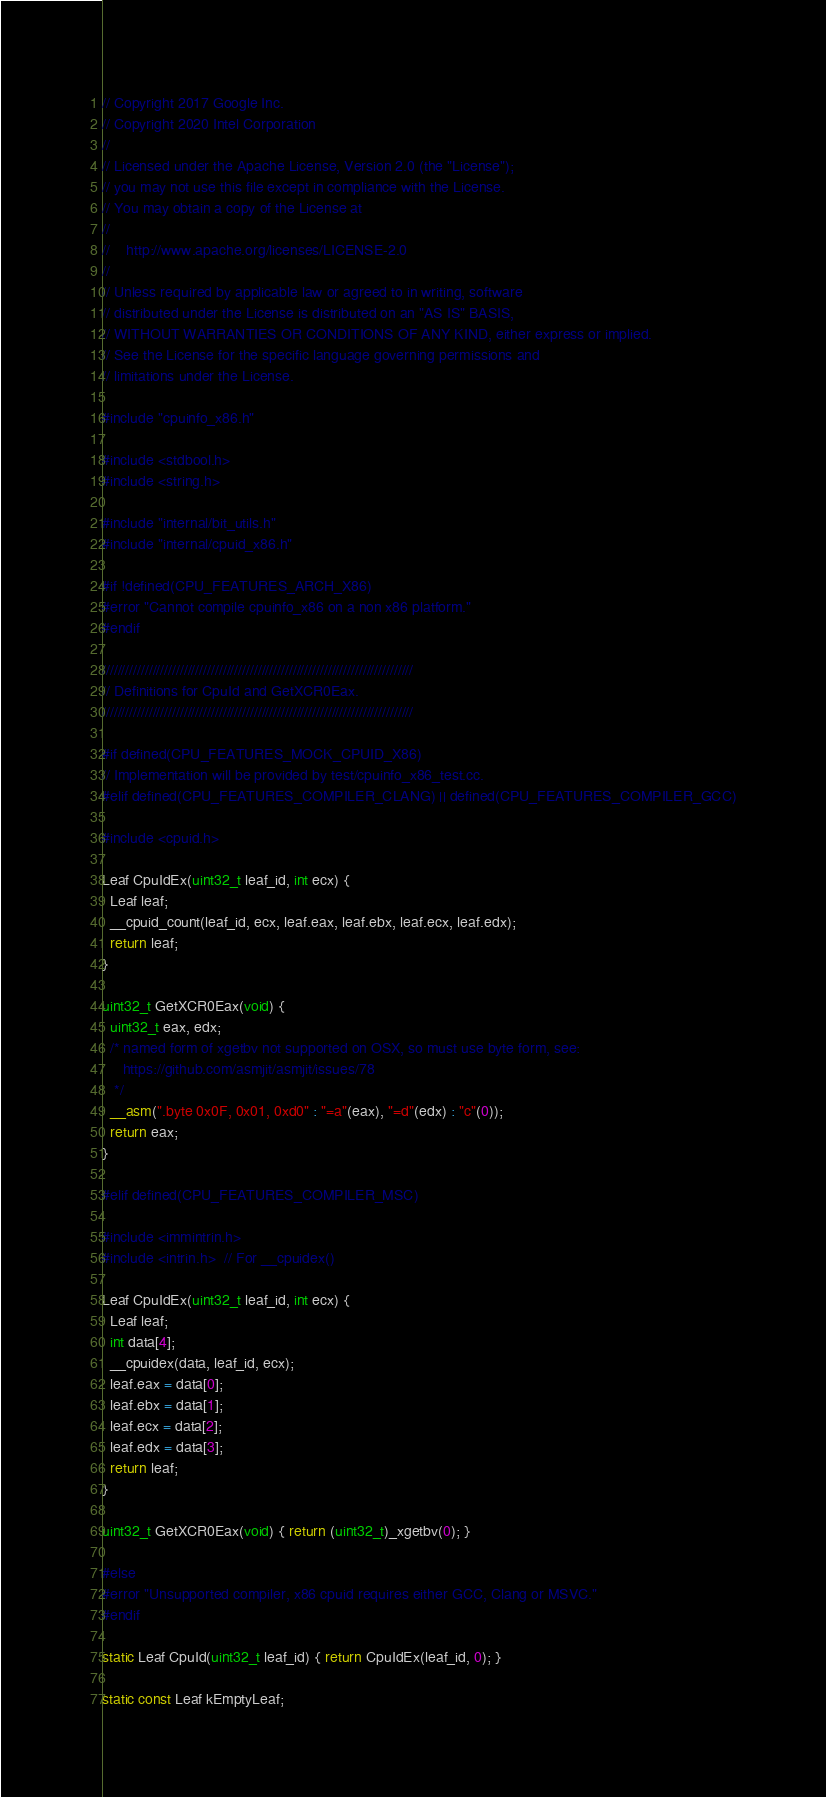<code> <loc_0><loc_0><loc_500><loc_500><_C_>// Copyright 2017 Google Inc.
// Copyright 2020 Intel Corporation
//
// Licensed under the Apache License, Version 2.0 (the "License");
// you may not use this file except in compliance with the License.
// You may obtain a copy of the License at
//
//    http://www.apache.org/licenses/LICENSE-2.0
//
// Unless required by applicable law or agreed to in writing, software
// distributed under the License is distributed on an "AS IS" BASIS,
// WITHOUT WARRANTIES OR CONDITIONS OF ANY KIND, either express or implied.
// See the License for the specific language governing permissions and
// limitations under the License.

#include "cpuinfo_x86.h"

#include <stdbool.h>
#include <string.h>

#include "internal/bit_utils.h"
#include "internal/cpuid_x86.h"

#if !defined(CPU_FEATURES_ARCH_X86)
#error "Cannot compile cpuinfo_x86 on a non x86 platform."
#endif

////////////////////////////////////////////////////////////////////////////////
// Definitions for CpuId and GetXCR0Eax.
////////////////////////////////////////////////////////////////////////////////

#if defined(CPU_FEATURES_MOCK_CPUID_X86)
// Implementation will be provided by test/cpuinfo_x86_test.cc.
#elif defined(CPU_FEATURES_COMPILER_CLANG) || defined(CPU_FEATURES_COMPILER_GCC)

#include <cpuid.h>

Leaf CpuIdEx(uint32_t leaf_id, int ecx) {
  Leaf leaf;
  __cpuid_count(leaf_id, ecx, leaf.eax, leaf.ebx, leaf.ecx, leaf.edx);
  return leaf;
}

uint32_t GetXCR0Eax(void) {
  uint32_t eax, edx;
  /* named form of xgetbv not supported on OSX, so must use byte form, see:
     https://github.com/asmjit/asmjit/issues/78
   */
  __asm(".byte 0x0F, 0x01, 0xd0" : "=a"(eax), "=d"(edx) : "c"(0));
  return eax;
}

#elif defined(CPU_FEATURES_COMPILER_MSC)

#include <immintrin.h>
#include <intrin.h>  // For __cpuidex()

Leaf CpuIdEx(uint32_t leaf_id, int ecx) {
  Leaf leaf;
  int data[4];
  __cpuidex(data, leaf_id, ecx);
  leaf.eax = data[0];
  leaf.ebx = data[1];
  leaf.ecx = data[2];
  leaf.edx = data[3];
  return leaf;
}

uint32_t GetXCR0Eax(void) { return (uint32_t)_xgetbv(0); }

#else
#error "Unsupported compiler, x86 cpuid requires either GCC, Clang or MSVC."
#endif

static Leaf CpuId(uint32_t leaf_id) { return CpuIdEx(leaf_id, 0); }

static const Leaf kEmptyLeaf;
</code> 